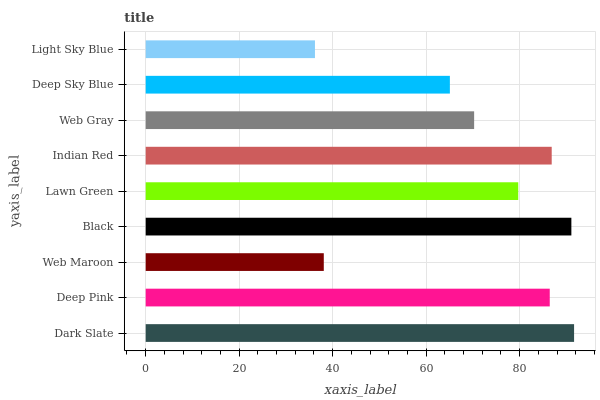Is Light Sky Blue the minimum?
Answer yes or no. Yes. Is Dark Slate the maximum?
Answer yes or no. Yes. Is Deep Pink the minimum?
Answer yes or no. No. Is Deep Pink the maximum?
Answer yes or no. No. Is Dark Slate greater than Deep Pink?
Answer yes or no. Yes. Is Deep Pink less than Dark Slate?
Answer yes or no. Yes. Is Deep Pink greater than Dark Slate?
Answer yes or no. No. Is Dark Slate less than Deep Pink?
Answer yes or no. No. Is Lawn Green the high median?
Answer yes or no. Yes. Is Lawn Green the low median?
Answer yes or no. Yes. Is Deep Pink the high median?
Answer yes or no. No. Is Dark Slate the low median?
Answer yes or no. No. 